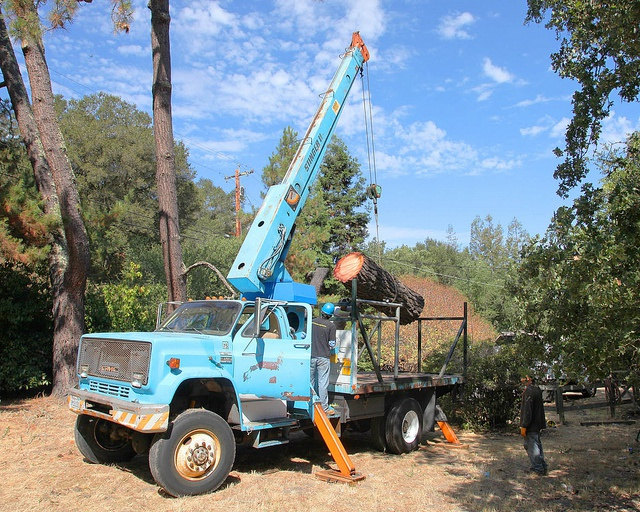Describe the objects in this image and their specific colors. I can see truck in salmon, black, gray, lightblue, and darkgray tones, people in salmon, gray, darkgray, and lightblue tones, people in salmon, black, gray, and maroon tones, and people in salmon, tan, gray, and darkgray tones in this image. 